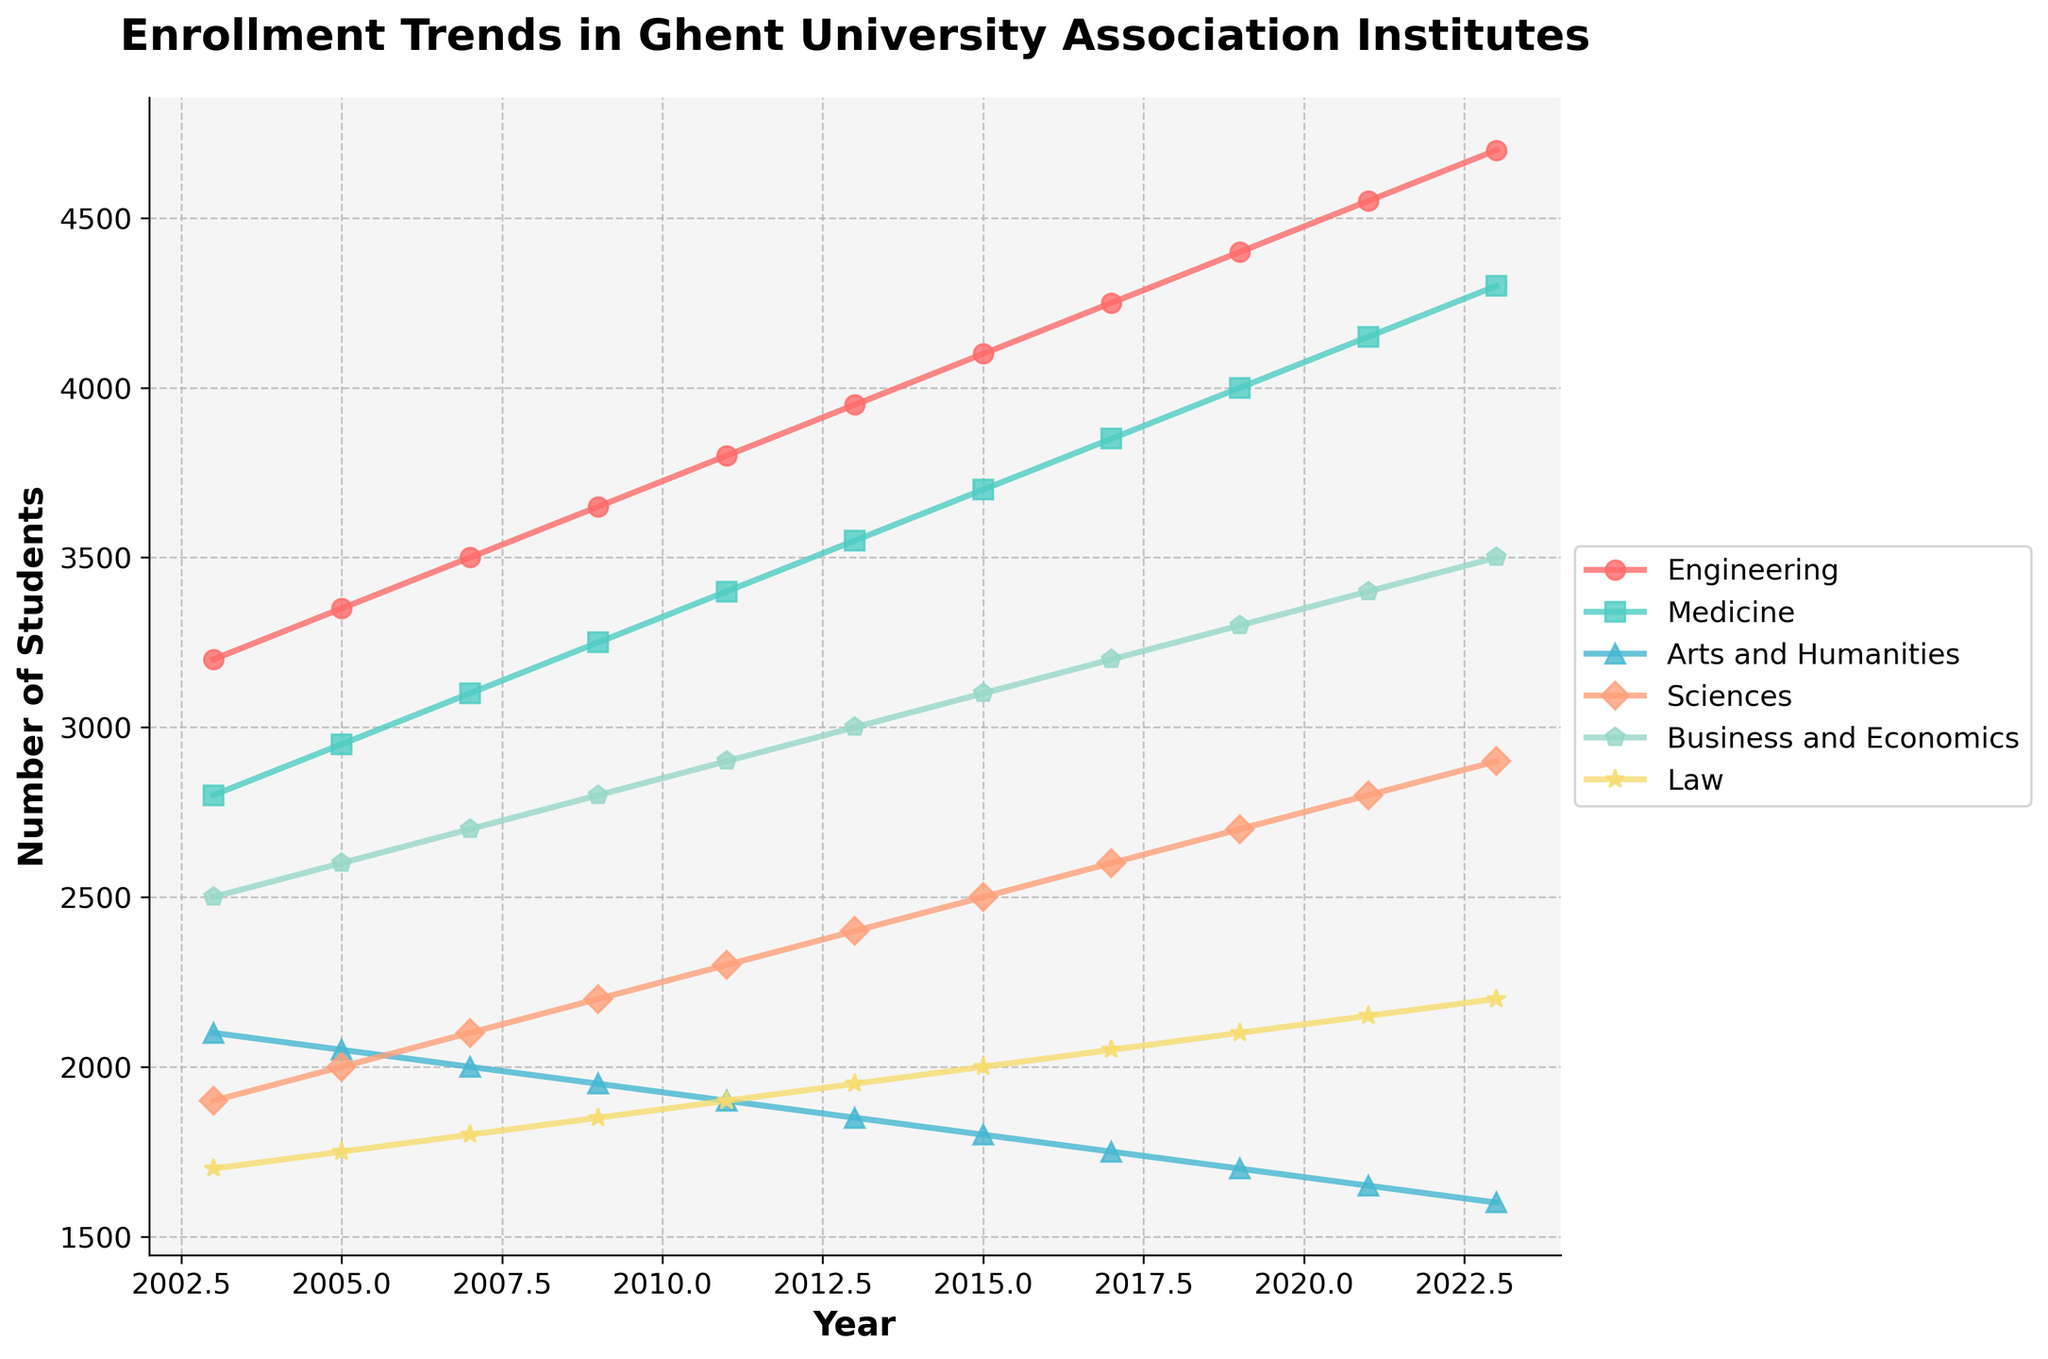Which field of study saw the smallest increase in enrollment from 2003 to 2023? To find this, we look at the enrollment numbers in 2003 and 2023 for each field and calculate the difference. For Arts and Humanities, the increase is 1600 - 2100 = -500. For others: Engineering 4700-3200=1500, Medicine 4300-2800=1500, Sciences 2900-1900=1000, Business and Economics 3500-2500=1000, Law 2200-1700=500. Clearly, Arts and Humanities had the smallest (negative) increase.
Answer: Arts and Humanities Which year had the highest total enrollment across all fields of study? Calculate the sum of enrollments for all fields for each year and compare. For example, in 2003: 3200+2800+2100+1900+2500+1700=14200. Repeat this for all years and compare the resulting totals to find the highest. For 2023, the sum is 4700+4300+1600+2900+3500+2200=19200, which is the highest.
Answer: 2023 Which two fields had a crossover in their levels of enrollment between 2007 and 2011? A crossover in enrollment is when one field overtakes another. We look for pairs of lines that cross each other between 2007 and 2011. Engineering overtakes Medicine (3500 < 3100 in 2007 and 3800 > 3400 in 2011). This means they crossed over between these years.
Answer: Engineering and Medicine What is the average enrollment in Engineering from 2003 to 2023? Add the enrollment numbers for Engineering from 2003 to 2023 and then divide by the number of years (11). (3200+3350+3500+3650+3800+3950+4100+4250+4400+4550+4700)/11 = 3940
Answer: 3940 Which field experienced the most consistent growth over the 20 years? To find this, we examine the trends visually and determine which field shows a relatively smooth, linear increase. Engineering's line is quite consistent from 3200 in 2003 to 4700 in 2023 compared to others.
Answer: Engineering In which period did Medicine see the most significant increase in enrollment? Identify the two years between which the increase in enrollment for Medicine was the greatest by looking at the slope of the line. Enrollment went from 2800 in 2003 to 2950 in 2005, a difference of 150. The largest increase occurred between 2021 and 2023 (from 4150 to 4300), which is 150.
Answer: 2021-2023 Between Sciences and Business and Economics, which had a higher enrollment in 2019? Compare the enrollment numbers in 2019 for Sciences (2700) and Business and Economics (3300). Business and Economics had the higher number.
Answer: Business and Economics What was the trend in enrollment for Law from 2003 to 2023? Look at the Law data points from 2003 (1700) to 2023 (2200). The increase is steady though gradual. It starts at 1700 and reaches 2200, showing a slow uptrend.
Answer: Increasing gradually By how much did the total enrollment in Sciences change from 2003 to 2023? Subtract the 2003 figure for Sciences (1900) from the 2023 figure (2900): 2900-1900=1000.
Answer: 1000 